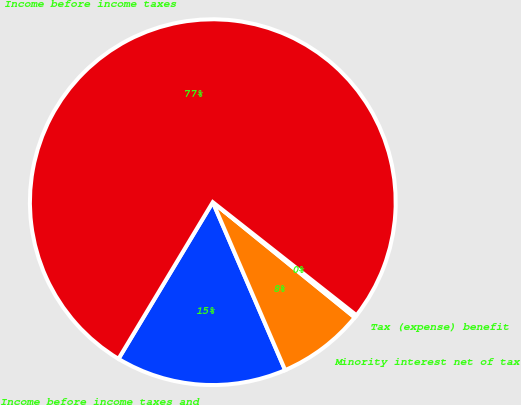<chart> <loc_0><loc_0><loc_500><loc_500><pie_chart><fcel>Income before income taxes and<fcel>Minority interest net of tax<fcel>Tax (expense) benefit<fcel>Income before income taxes<nl><fcel>15.1%<fcel>7.67%<fcel>0.24%<fcel>76.99%<nl></chart> 